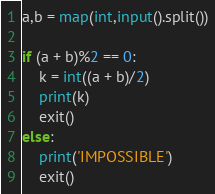<code> <loc_0><loc_0><loc_500><loc_500><_Python_>a,b = map(int,input().split())

if (a + b)%2 == 0:
    k = int((a + b)/2)
    print(k)
    exit()
else:
    print('IMPOSSIBLE')
    exit()
</code> 